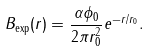<formula> <loc_0><loc_0><loc_500><loc_500>B _ { \text {exp} } ( r ) = \frac { \alpha \phi _ { 0 } } { 2 \pi r _ { 0 } ^ { 2 } } e ^ { - r / r _ { 0 } } .</formula> 